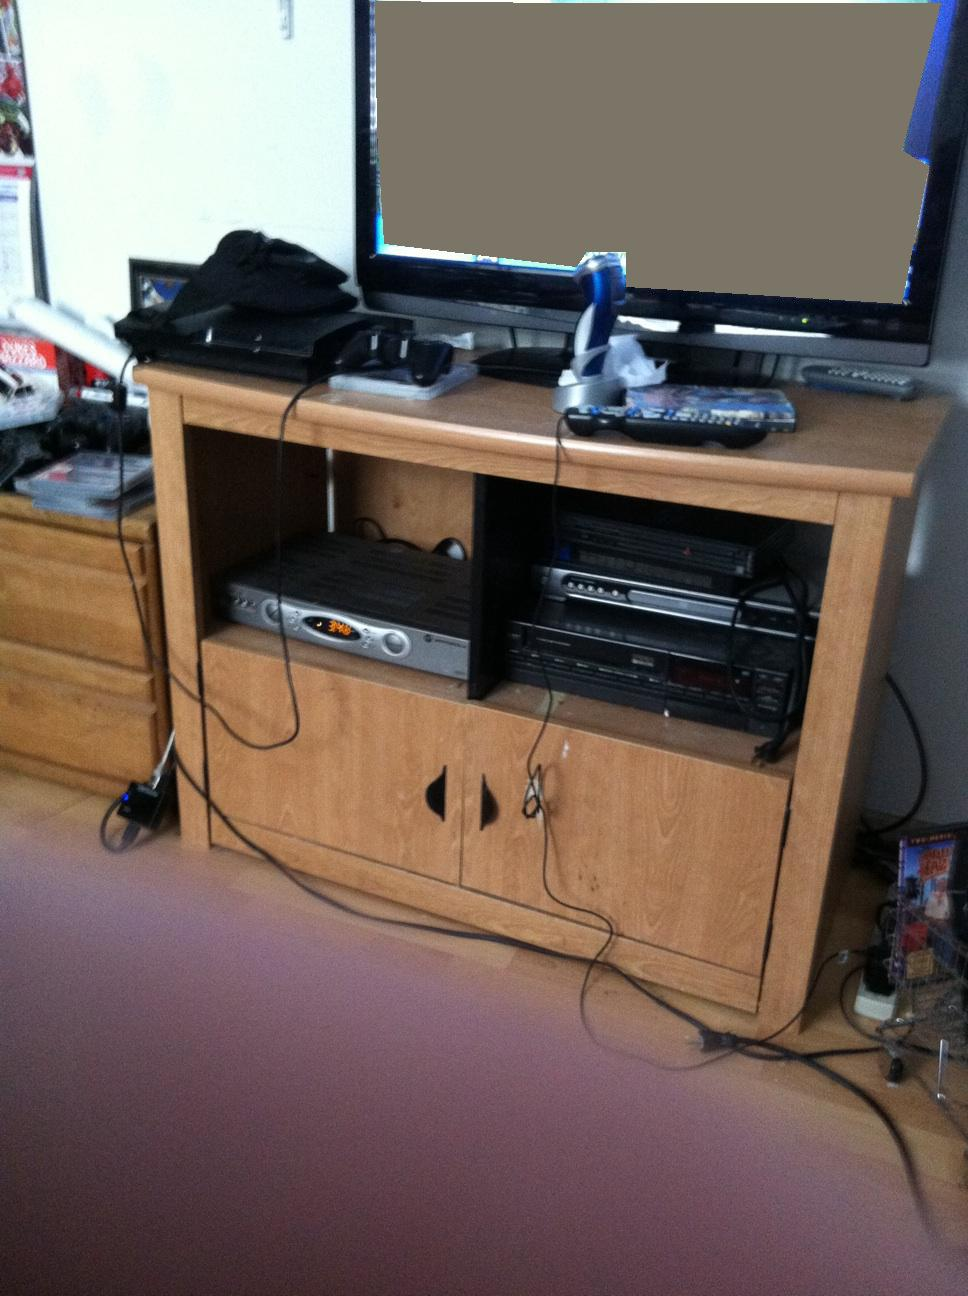Can you tell me what devices are shown in the image? The image includes a desktop monitor, a gaming console (PlayStation), a DVD player, and a stereo system neatly arranged on a wooden desk. Are there any signs of entertainment apart from gaming devices? Yes, there are multiple remote controls and a DVD player, suggesting the use of the setup for watching movies or listening to music in addition to gaming. 